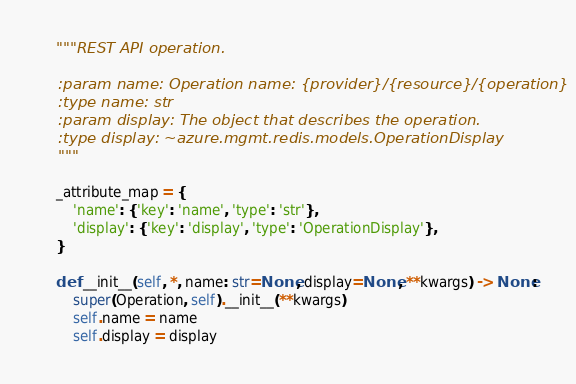Convert code to text. <code><loc_0><loc_0><loc_500><loc_500><_Python_>    """REST API operation.

    :param name: Operation name: {provider}/{resource}/{operation}
    :type name: str
    :param display: The object that describes the operation.
    :type display: ~azure.mgmt.redis.models.OperationDisplay
    """

    _attribute_map = {
        'name': {'key': 'name', 'type': 'str'},
        'display': {'key': 'display', 'type': 'OperationDisplay'},
    }

    def __init__(self, *, name: str=None, display=None, **kwargs) -> None:
        super(Operation, self).__init__(**kwargs)
        self.name = name
        self.display = display
</code> 